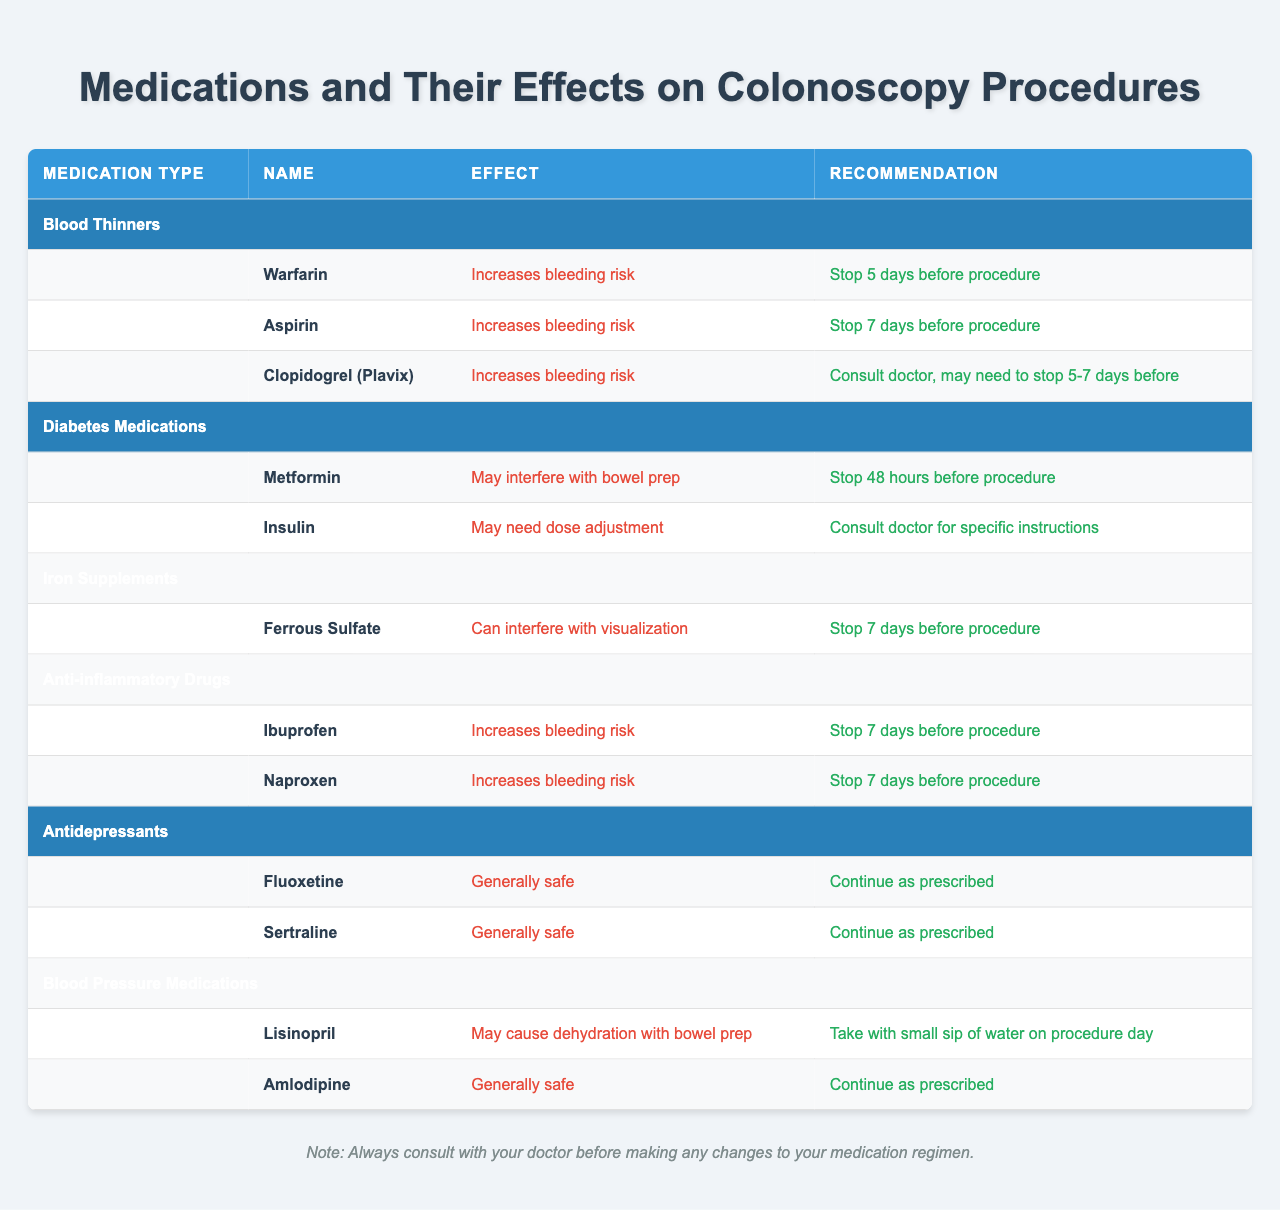What should I do with Warfarin before my colonoscopy? According to the table, Warfarin increases bleeding risk, and the recommendation is to stop taking it 5 days before the procedure.
Answer: Stop 5 days before Is Clopidogrel (Plavix) safe to take before my colonoscopy? Clopidogrel (Plavix) increases bleeding risk, and the table advises consulting a doctor, as you may need to stop it 5-7 days before the procedure.
Answer: Consult doctor for advice Do I need to stop taking Metformin before my colonoscopy? The table indicates that Metformin may interfere with bowel prep, and it is recommended to stop taking it 48 hours before the procedure.
Answer: Yes, stop 48 hours before Are all antidepressants safe to continue before a colonoscopy? The table shows that both Fluoxetine and Sertraline are generally safe and the recommendation is to continue taking them as prescribed.
Answer: Yes, they are generally safe What is the effect of taking Iron Supplements like Ferrous Sulfate before a colonoscopy? The table states that Ferrous Sulfate can interfere with visualization during the procedure, and it is recommended to stop taking it 7 days before.
Answer: It can interfere with visualization How many days should I stop taking Ibuprofen before my colonoscopy? The table specifies that Ibuprofen should be stopped 7 days before the procedure due to increased bleeding risk.
Answer: Stop 7 days before If I take Lisinopril, what special instruction do I need to follow on the day of my colonoscopy? The table recommends taking Lisinopril with a small sip of water on the procedure day due to the potential for dehydration with bowel prep.
Answer: Take with a small sip of water on the day Is Amlodipine considered safe to take right before a colonoscopy? The table states that Amlodipine is generally safe and should be continued as prescribed, which suggests it can be taken before the procedure without major concerns.
Answer: Yes, it is generally safe What is the most critical reason for stopping blood thinners before a colonoscopy? The table emphasizes that blood thinners increase the risk of bleeding, which is a significant concern for colonoscopy procedures.
Answer: Increased bleeding risk Would I need to adjust my Insulin dose before the colonoscopy? The table advises consulting a doctor for specific instructions regarding dose adjustments of Insulin before the procedure, as it may require changes depending on individual circumstances.
Answer: Yes, consult your doctor for adjustments 